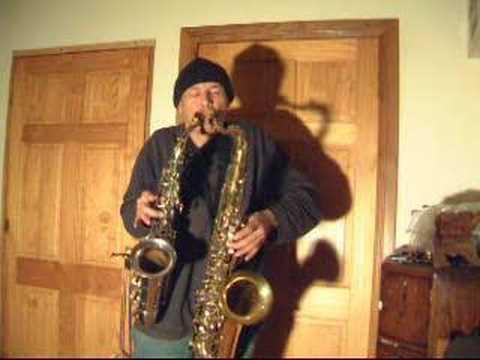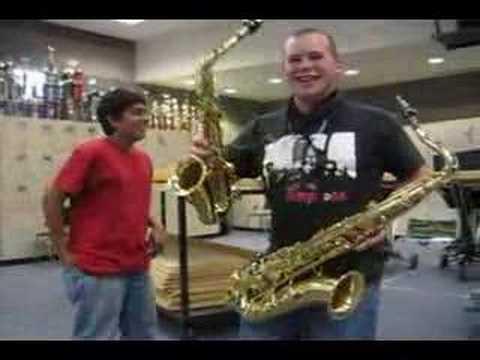The first image is the image on the left, the second image is the image on the right. Assess this claim about the two images: "An image shows two men side-by-side holding instruments, and at least one of them wears a black short-sleeved t-shirt.". Correct or not? Answer yes or no. No. 